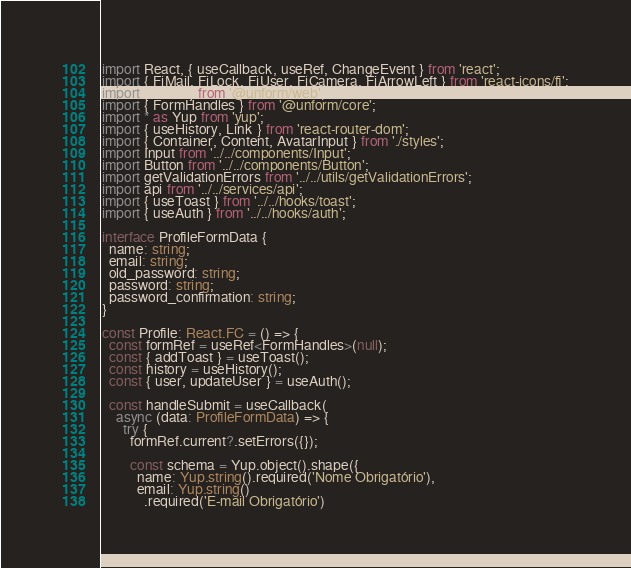Convert code to text. <code><loc_0><loc_0><loc_500><loc_500><_TypeScript_>import React, { useCallback, useRef, ChangeEvent } from 'react';
import { FiMail, FiLock, FiUser, FiCamera, FiArrowLeft } from 'react-icons/fi';
import { Form } from '@unform/web';
import { FormHandles } from '@unform/core';
import * as Yup from 'yup';
import { useHistory, Link } from 'react-router-dom';
import { Container, Content, AvatarInput } from './styles';
import Input from '../../components/Input';
import Button from '../../components/Button';
import getValidationErrors from '../../utils/getValidationErrors';
import api from '../../services/api';
import { useToast } from '../../hooks/toast';
import { useAuth } from '../../hooks/auth';

interface ProfileFormData {
  name: string;
  email: string;
  old_password: string;
  password: string;
  password_confirmation: string;
}

const Profile: React.FC = () => {
  const formRef = useRef<FormHandles>(null);
  const { addToast } = useToast();
  const history = useHistory();
  const { user, updateUser } = useAuth();

  const handleSubmit = useCallback(
    async (data: ProfileFormData) => {
      try {
        formRef.current?.setErrors({});

        const schema = Yup.object().shape({
          name: Yup.string().required('Nome Obrigatório'),
          email: Yup.string()
            .required('E-mail Obrigatório')</code> 